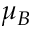<formula> <loc_0><loc_0><loc_500><loc_500>\mu _ { B }</formula> 